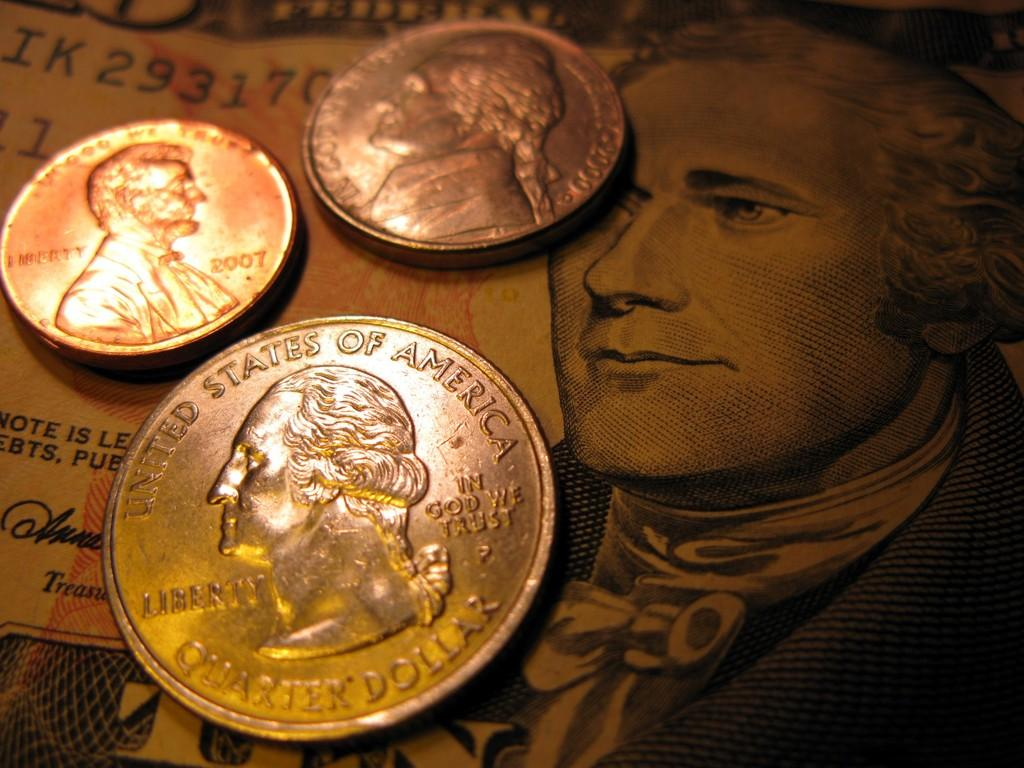<image>
Give a short and clear explanation of the subsequent image. The silver coin at the front is a quarter dollar coin. 